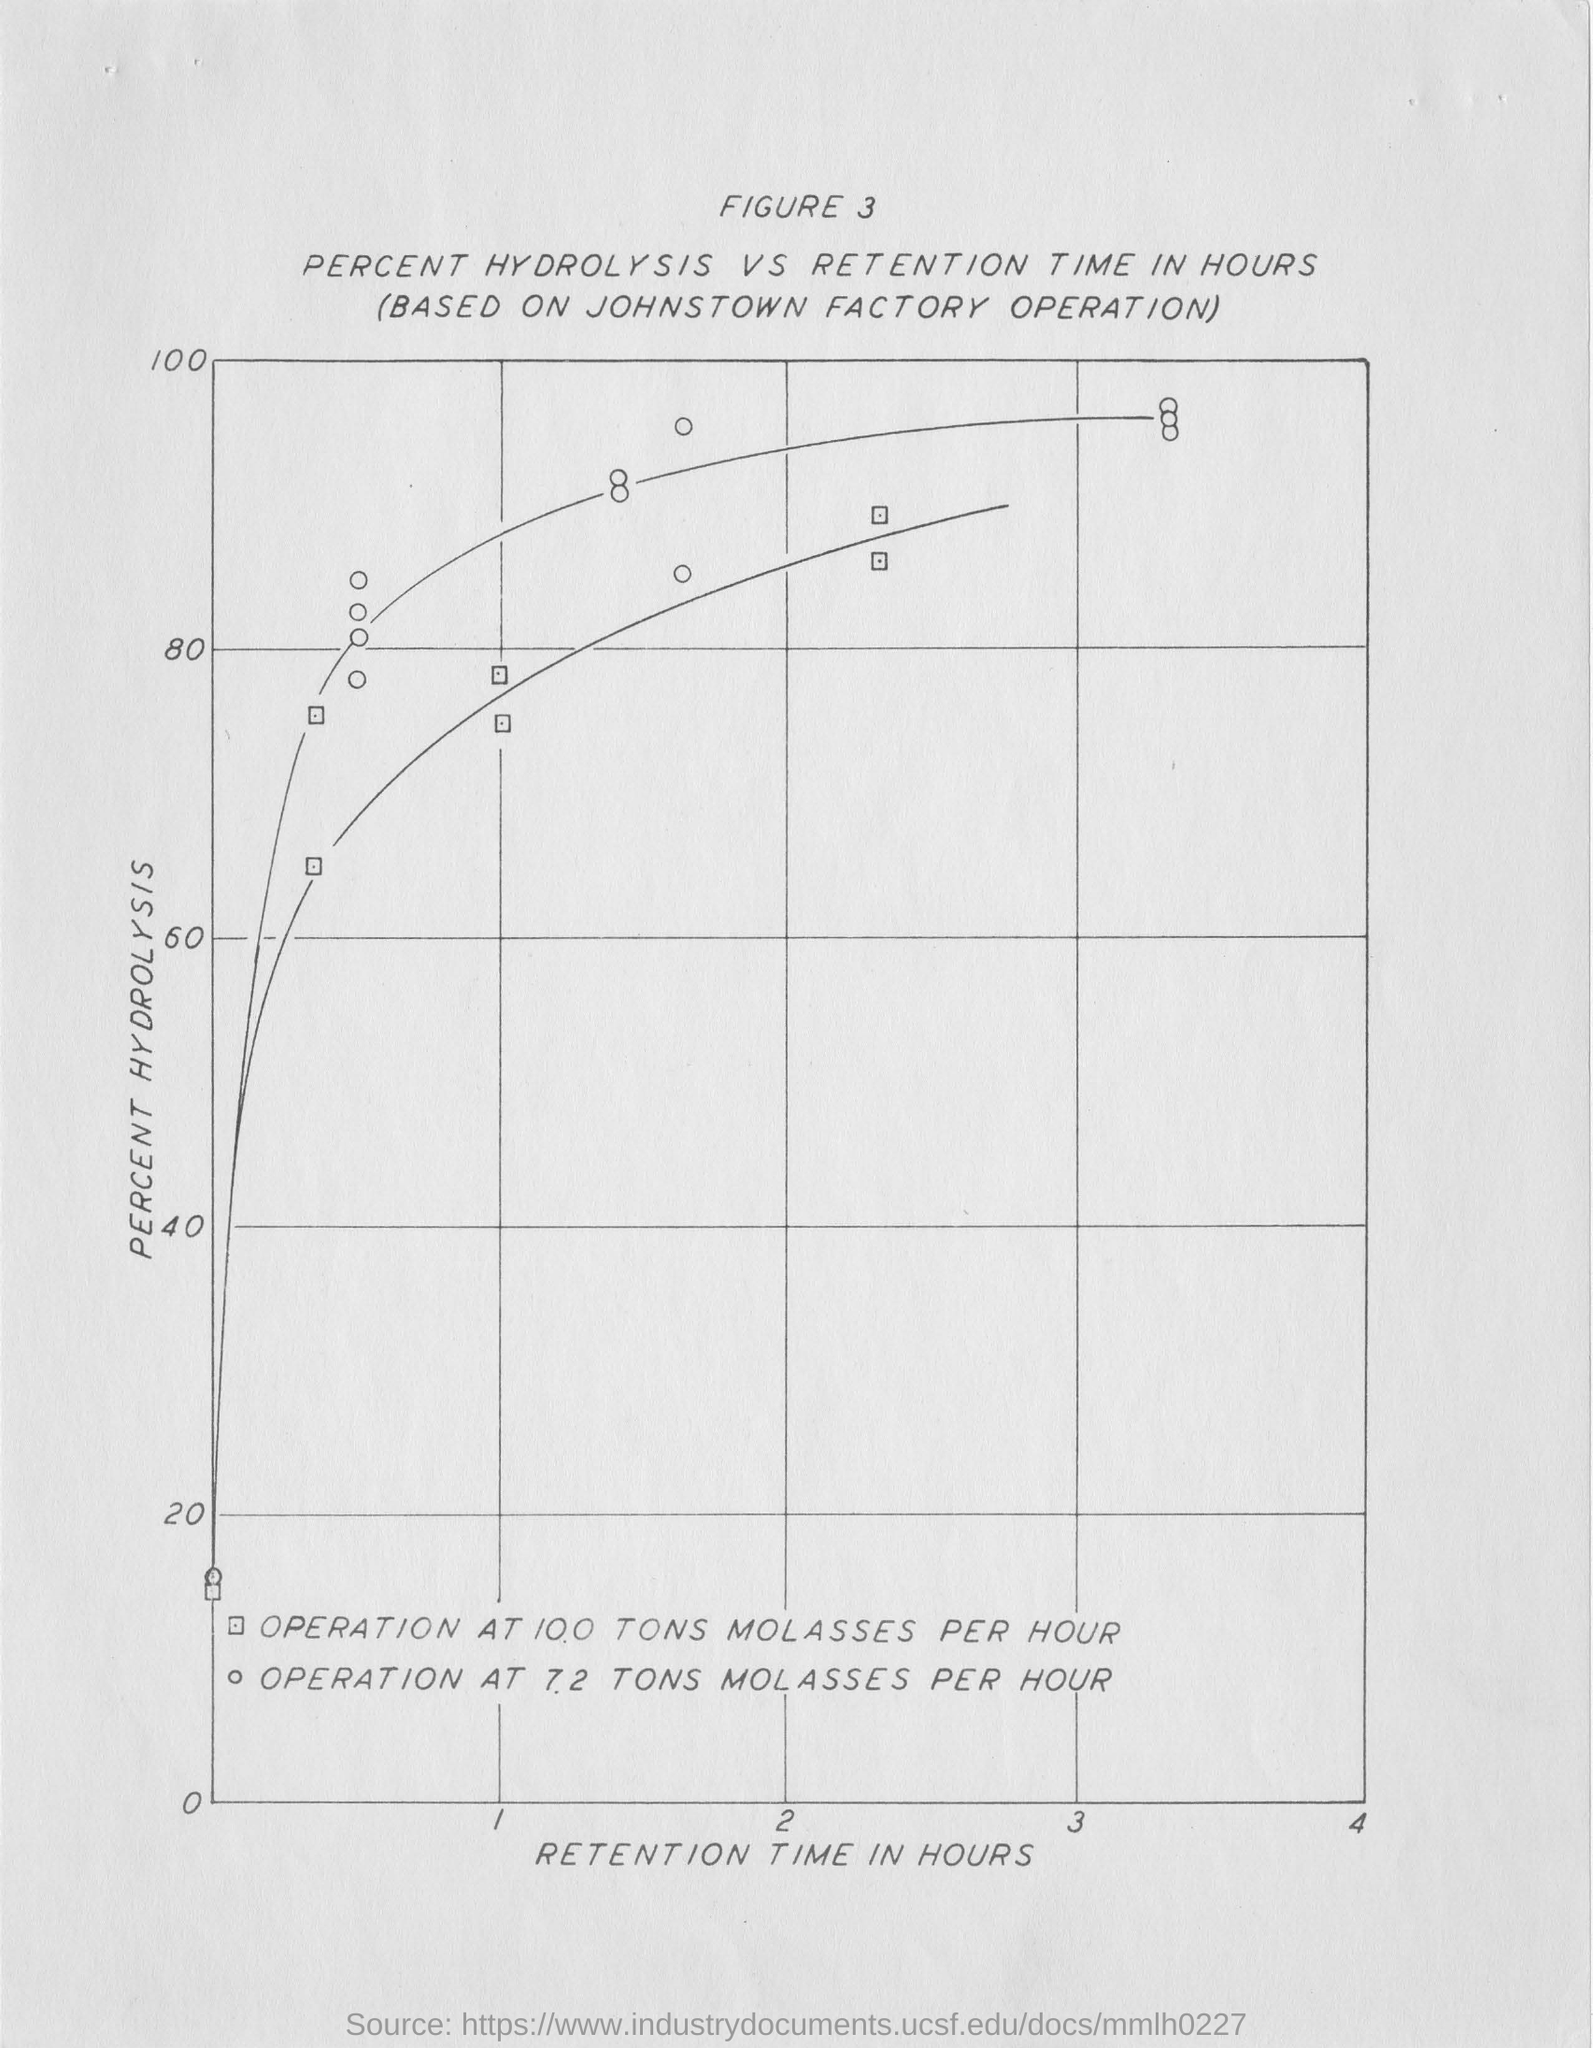Point out several critical features in this image. The y-axis in the graph represents the percentage of hydrolysis of the polysaccharide. The x-axis in the plot displays the retention time in hours, which is a measure of how long a particular compound remains in a chromatography column. 